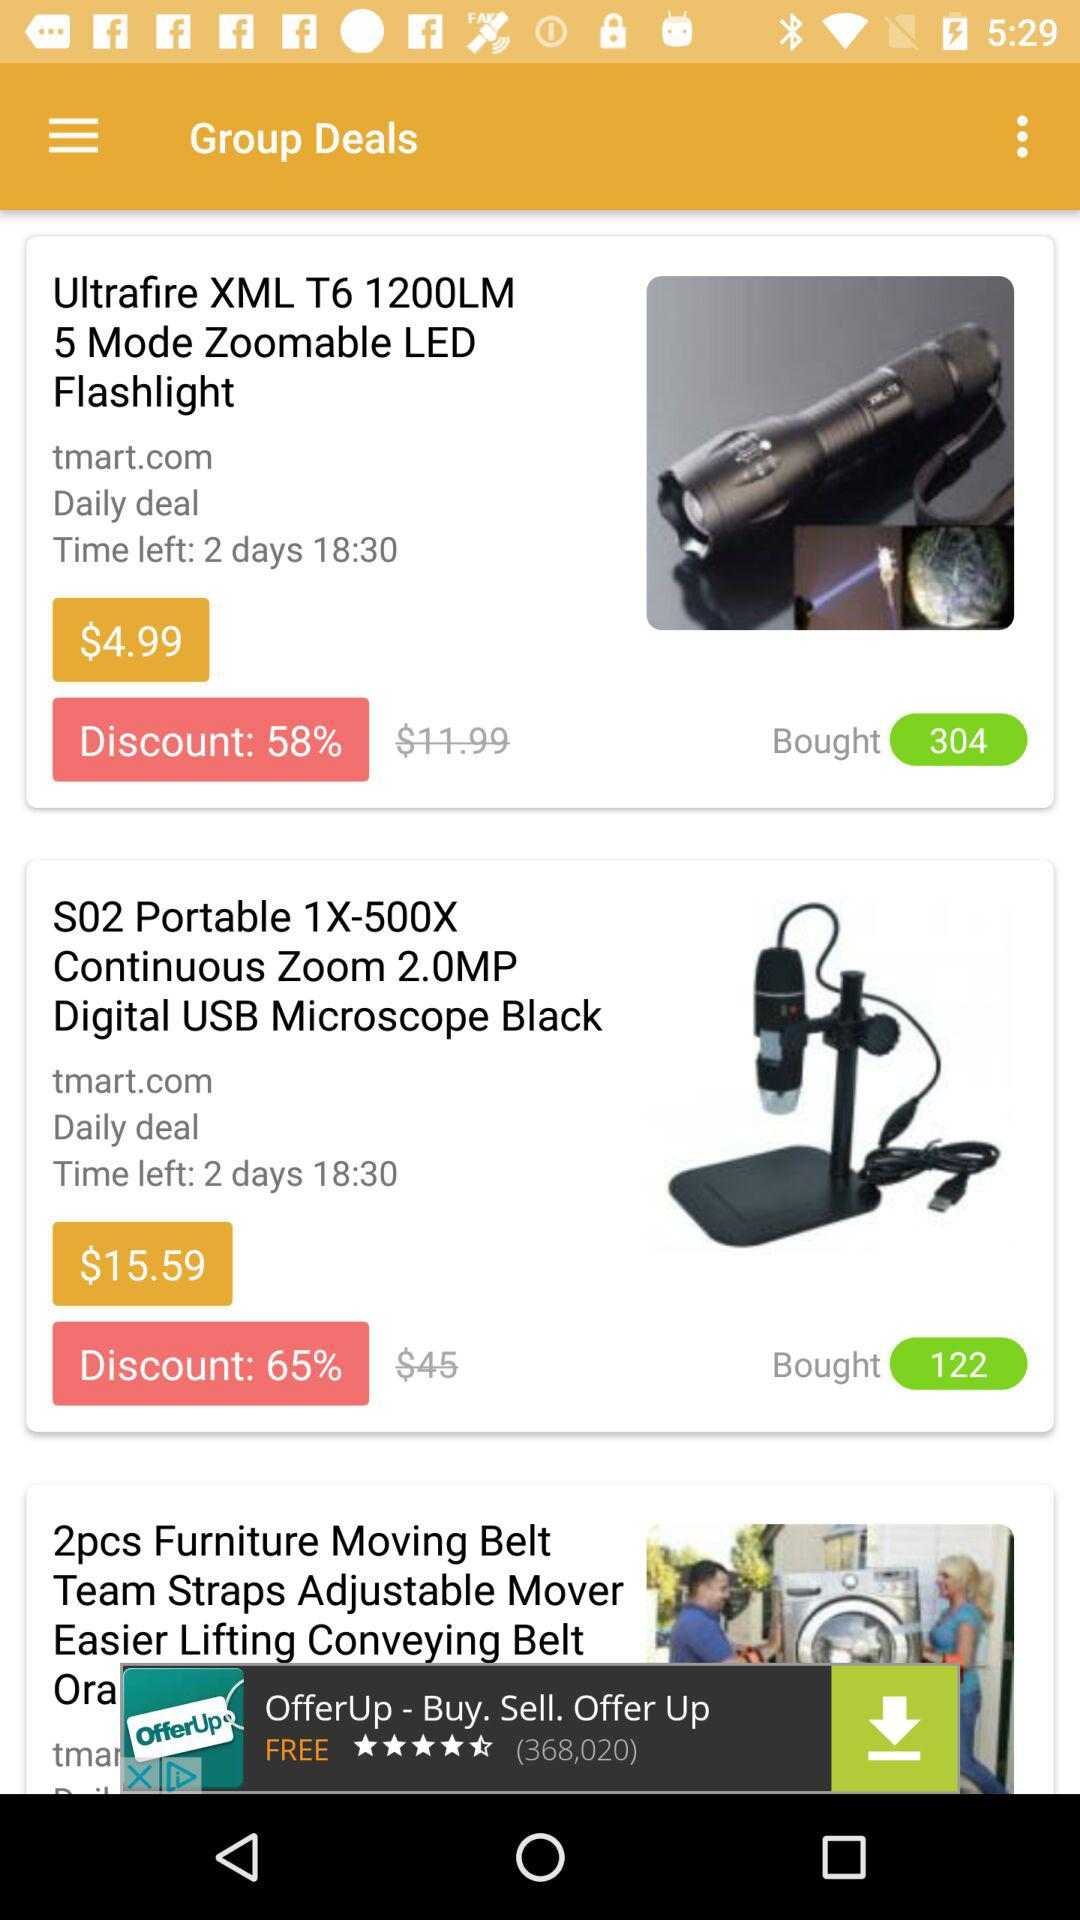How many of the items have a daily deal?
Answer the question using a single word or phrase. 2 